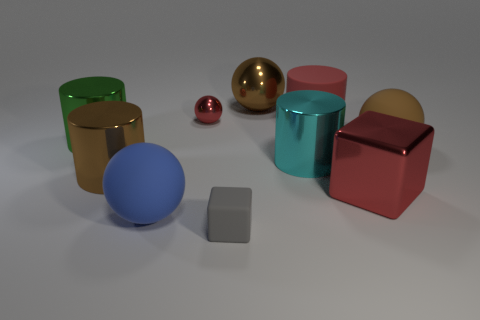Subtract 1 balls. How many balls are left? 3 Subtract all balls. How many objects are left? 6 Add 6 red things. How many red things exist? 9 Subtract 1 red cylinders. How many objects are left? 9 Subtract all cyan cylinders. Subtract all big green cylinders. How many objects are left? 8 Add 8 tiny shiny objects. How many tiny shiny objects are left? 9 